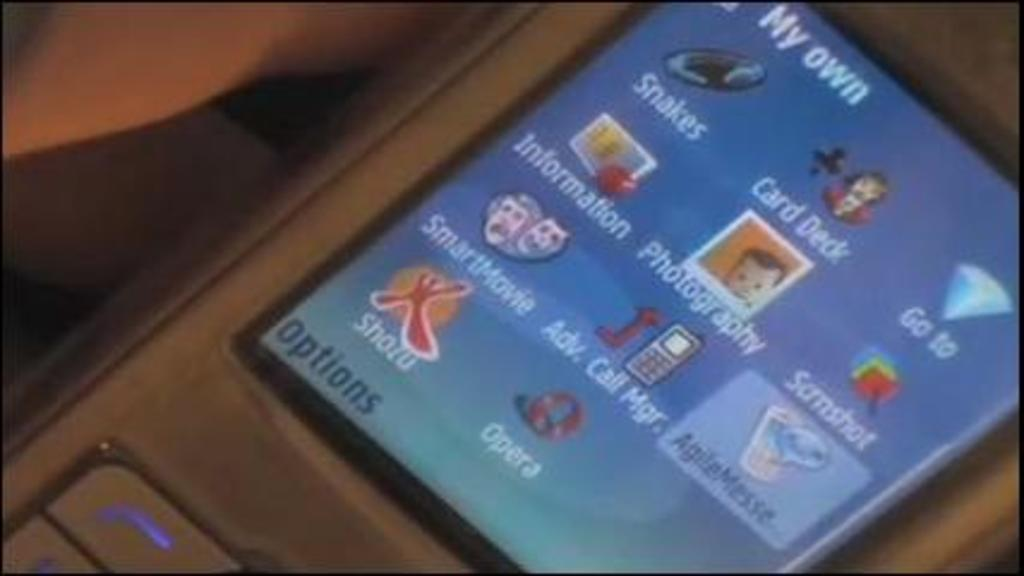<image>
Write a terse but informative summary of the picture. A cell phone screen displaying different apps including Card Deck and Snakes. 